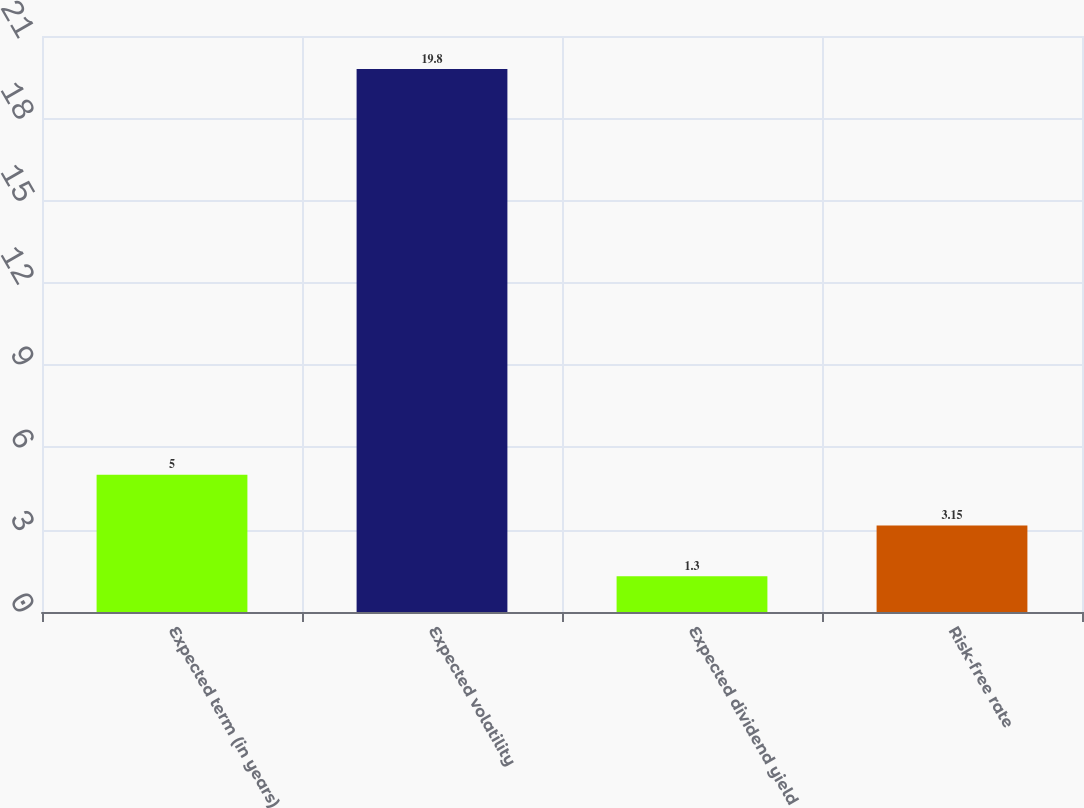<chart> <loc_0><loc_0><loc_500><loc_500><bar_chart><fcel>Expected term (in years)<fcel>Expected volatility<fcel>Expected dividend yield<fcel>Risk-free rate<nl><fcel>5<fcel>19.8<fcel>1.3<fcel>3.15<nl></chart> 